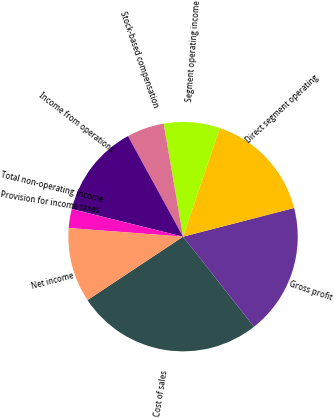Convert chart. <chart><loc_0><loc_0><loc_500><loc_500><pie_chart><fcel>Cost of sales<fcel>Gross profit<fcel>Direct segment operating<fcel>Segment operating income<fcel>Stock-based compensation<fcel>Income from operations<fcel>Total non-operating income<fcel>Provision for income taxes<fcel>Net income<nl><fcel>26.29%<fcel>18.41%<fcel>15.78%<fcel>7.9%<fcel>5.27%<fcel>13.15%<fcel>0.02%<fcel>2.65%<fcel>10.53%<nl></chart> 